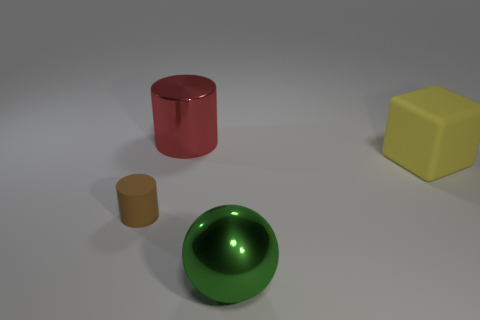The small rubber thing has what color?
Your answer should be very brief. Brown. Is the number of green things on the left side of the green metal thing less than the number of brown matte objects?
Offer a terse response. Yes. Is there any other thing that is the same shape as the big green metal thing?
Make the answer very short. No. Are there any big red rubber spheres?
Make the answer very short. No. Are there fewer tiny green objects than small objects?
Ensure brevity in your answer.  Yes. What number of purple cubes have the same material as the brown cylinder?
Ensure brevity in your answer.  0. The other thing that is made of the same material as the big red thing is what color?
Give a very brief answer. Green. The small brown rubber thing has what shape?
Make the answer very short. Cylinder. What number of big shiny balls have the same color as the tiny cylinder?
Provide a short and direct response. 0. The rubber object that is the same size as the sphere is what shape?
Keep it short and to the point. Cube. 